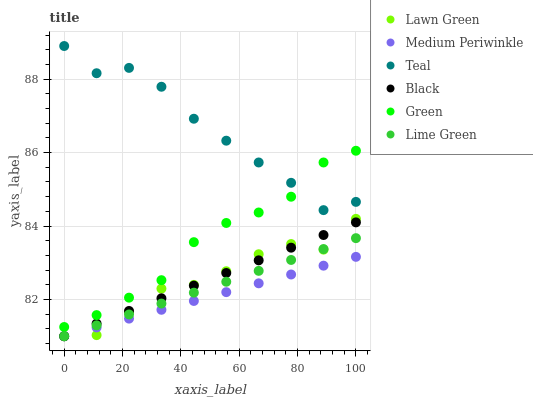Does Medium Periwinkle have the minimum area under the curve?
Answer yes or no. Yes. Does Teal have the maximum area under the curve?
Answer yes or no. Yes. Does Green have the minimum area under the curve?
Answer yes or no. No. Does Green have the maximum area under the curve?
Answer yes or no. No. Is Medium Periwinkle the smoothest?
Answer yes or no. Yes. Is Teal the roughest?
Answer yes or no. Yes. Is Green the smoothest?
Answer yes or no. No. Is Green the roughest?
Answer yes or no. No. Does Lawn Green have the lowest value?
Answer yes or no. Yes. Does Green have the lowest value?
Answer yes or no. No. Does Teal have the highest value?
Answer yes or no. Yes. Does Green have the highest value?
Answer yes or no. No. Is Black less than Green?
Answer yes or no. Yes. Is Teal greater than Medium Periwinkle?
Answer yes or no. Yes. Does Lime Green intersect Lawn Green?
Answer yes or no. Yes. Is Lime Green less than Lawn Green?
Answer yes or no. No. Is Lime Green greater than Lawn Green?
Answer yes or no. No. Does Black intersect Green?
Answer yes or no. No. 